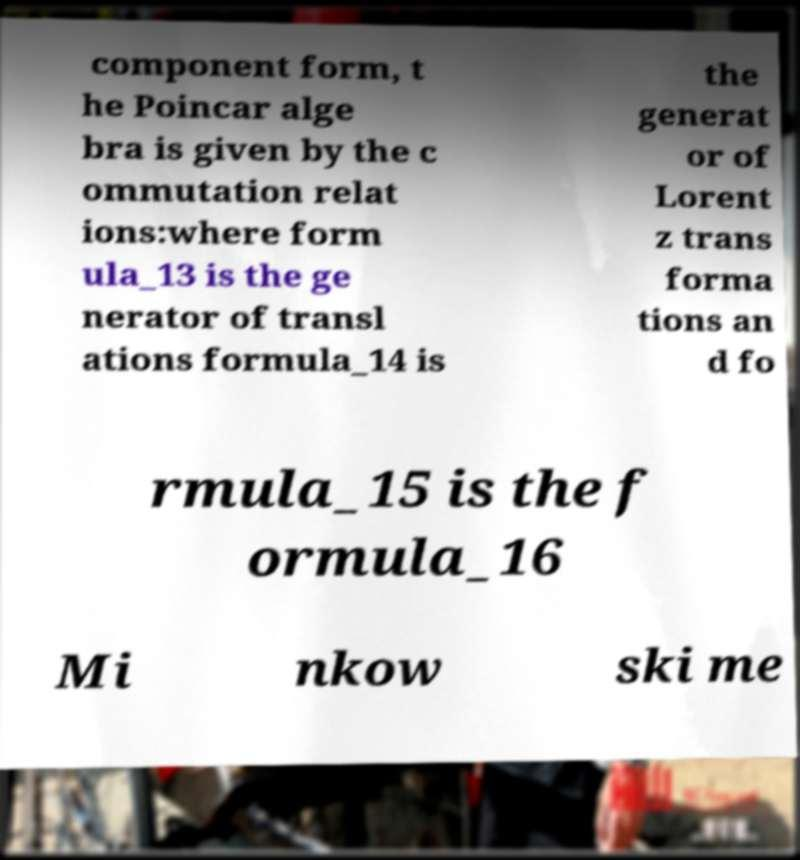What messages or text are displayed in this image? I need them in a readable, typed format. component form, t he Poincar alge bra is given by the c ommutation relat ions:where form ula_13 is the ge nerator of transl ations formula_14 is the generat or of Lorent z trans forma tions an d fo rmula_15 is the f ormula_16 Mi nkow ski me 